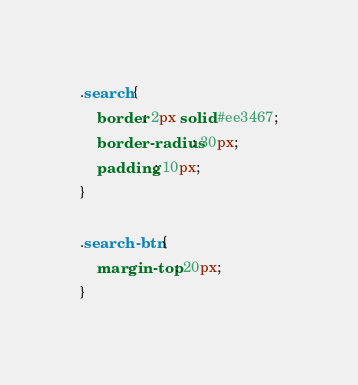<code> <loc_0><loc_0><loc_500><loc_500><_CSS_>.search {
	border: 2px solid #ee3467;
	border-radius: 30px;
	padding: 10px;
}

.search-btn {
	margin-top: 20px;
}
</code> 